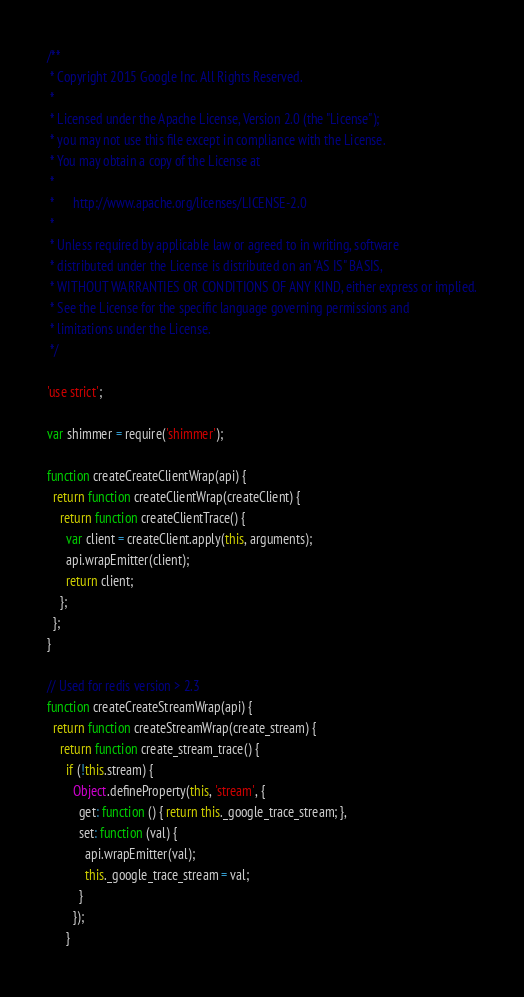Convert code to text. <code><loc_0><loc_0><loc_500><loc_500><_TypeScript_>/**
 * Copyright 2015 Google Inc. All Rights Reserved.
 *
 * Licensed under the Apache License, Version 2.0 (the "License");
 * you may not use this file except in compliance with the License.
 * You may obtain a copy of the License at
 *
 *      http://www.apache.org/licenses/LICENSE-2.0
 *
 * Unless required by applicable law or agreed to in writing, software
 * distributed under the License is distributed on an "AS IS" BASIS,
 * WITHOUT WARRANTIES OR CONDITIONS OF ANY KIND, either express or implied.
 * See the License for the specific language governing permissions and
 * limitations under the License.
 */

'use strict';

var shimmer = require('shimmer');

function createCreateClientWrap(api) {
  return function createClientWrap(createClient) {
    return function createClientTrace() {
      var client = createClient.apply(this, arguments);
      api.wrapEmitter(client);
      return client;
    };
  };
}

// Used for redis version > 2.3
function createCreateStreamWrap(api) {
  return function createStreamWrap(create_stream) {
    return function create_stream_trace() {
      if (!this.stream) {
        Object.defineProperty(this, 'stream', {
          get: function () { return this._google_trace_stream; },
          set: function (val) {
            api.wrapEmitter(val);
            this._google_trace_stream = val;
          }
        });
      }</code> 